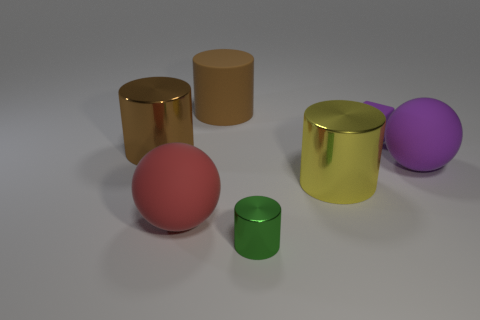Subtract all brown shiny cylinders. How many cylinders are left? 3 Subtract all red balls. How many balls are left? 1 Subtract all cylinders. How many objects are left? 3 Add 3 big matte cylinders. How many objects exist? 10 Subtract all cyan cylinders. How many red spheres are left? 1 Subtract all big shiny cylinders. Subtract all big cylinders. How many objects are left? 2 Add 1 large yellow shiny objects. How many large yellow shiny objects are left? 2 Add 6 small green matte cylinders. How many small green matte cylinders exist? 6 Subtract 0 blue spheres. How many objects are left? 7 Subtract 2 spheres. How many spheres are left? 0 